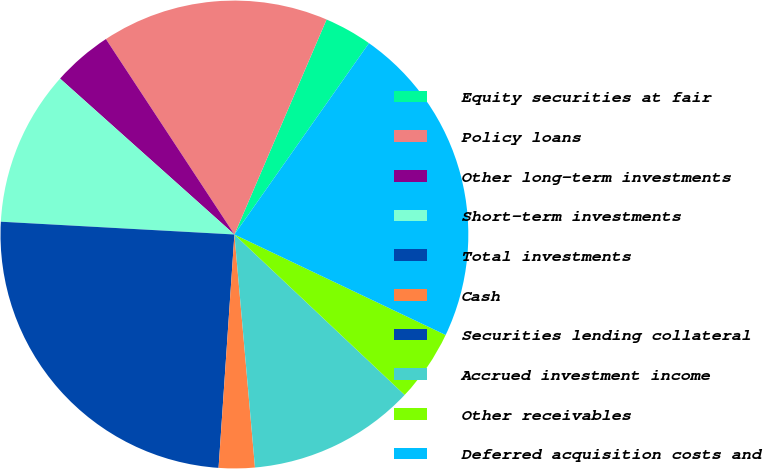Convert chart to OTSL. <chart><loc_0><loc_0><loc_500><loc_500><pie_chart><fcel>Equity securities at fair<fcel>Policy loans<fcel>Other long-term investments<fcel>Short-term investments<fcel>Total investments<fcel>Cash<fcel>Securities lending collateral<fcel>Accrued investment income<fcel>Other receivables<fcel>Deferred acquisition costs and<nl><fcel>3.31%<fcel>15.7%<fcel>4.13%<fcel>10.74%<fcel>24.79%<fcel>2.48%<fcel>0.0%<fcel>11.57%<fcel>4.96%<fcel>22.31%<nl></chart> 